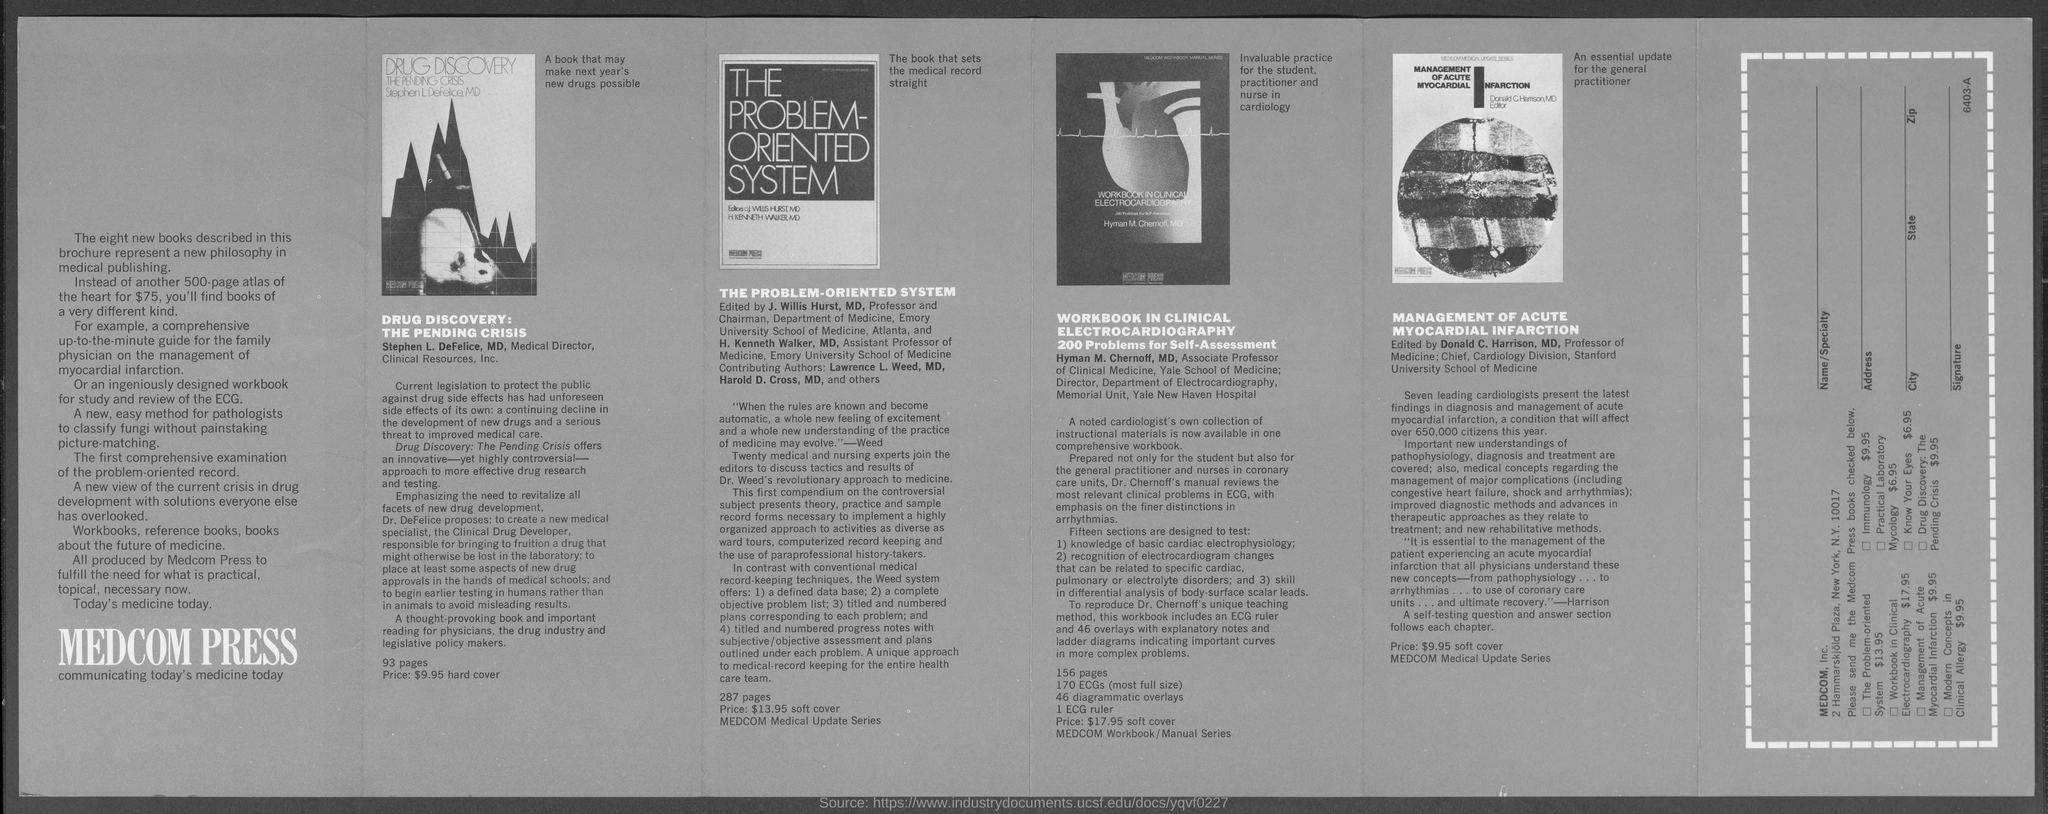Who is the author of the 'WORKBOOK IN CLINICAL ELECTROCARDIOGRAPHY'?
Your answer should be very brief. Hyman M. Chernoff. Who is the Chief, Cardiology Division, Stanford University School of Medicine?
Ensure brevity in your answer.  Donald C. Harrison, MD. Who is the author of the book ' DRUG DISCOVERY:THE PENDING CRISIS'?
Your answer should be compact. Stephen L. DeFelice, MD. What is the price of the book ' DRUG DISCOVERY:THE PENDING CRISIS'?
Your answer should be compact. $9.95 hard cover. What is the price of the book 'THE PROBLEM-ORIENTED SYSTEM'?
Keep it short and to the point. $13.95. 